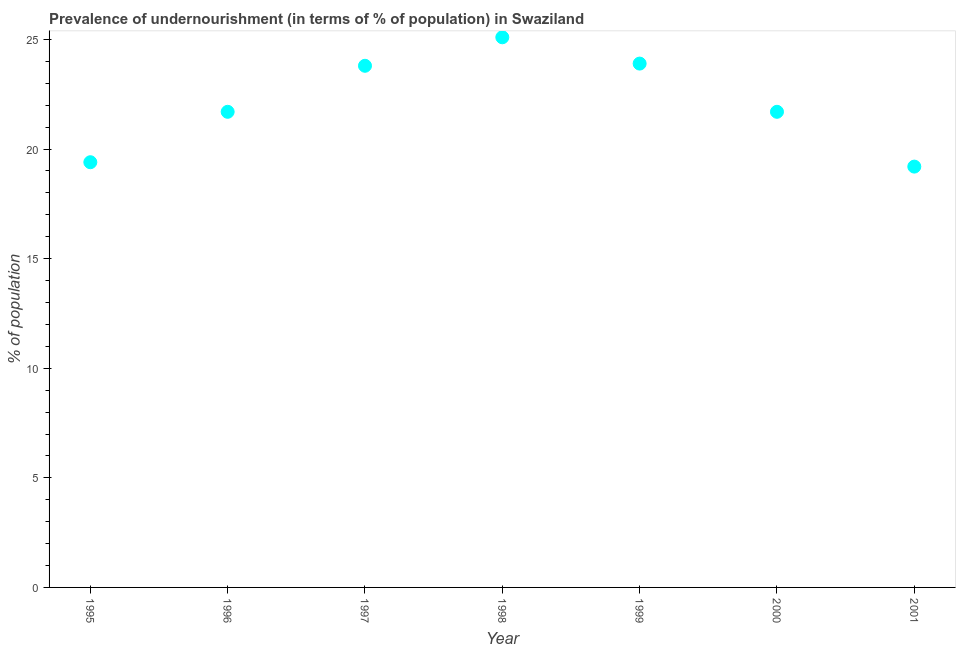What is the percentage of undernourished population in 1999?
Your answer should be compact. 23.9. Across all years, what is the maximum percentage of undernourished population?
Ensure brevity in your answer.  25.1. Across all years, what is the minimum percentage of undernourished population?
Your answer should be very brief. 19.2. In which year was the percentage of undernourished population maximum?
Give a very brief answer. 1998. What is the sum of the percentage of undernourished population?
Your response must be concise. 154.8. What is the difference between the percentage of undernourished population in 1996 and 1997?
Keep it short and to the point. -2.1. What is the average percentage of undernourished population per year?
Offer a terse response. 22.11. What is the median percentage of undernourished population?
Your response must be concise. 21.7. Do a majority of the years between 1997 and 1996 (inclusive) have percentage of undernourished population greater than 5 %?
Your answer should be very brief. No. What is the ratio of the percentage of undernourished population in 1998 to that in 2001?
Your response must be concise. 1.31. Is the difference between the percentage of undernourished population in 1998 and 2000 greater than the difference between any two years?
Provide a short and direct response. No. What is the difference between the highest and the second highest percentage of undernourished population?
Your answer should be very brief. 1.2. What is the difference between the highest and the lowest percentage of undernourished population?
Give a very brief answer. 5.9. Does the percentage of undernourished population monotonically increase over the years?
Offer a very short reply. No. What is the title of the graph?
Your answer should be very brief. Prevalence of undernourishment (in terms of % of population) in Swaziland. What is the label or title of the Y-axis?
Keep it short and to the point. % of population. What is the % of population in 1996?
Give a very brief answer. 21.7. What is the % of population in 1997?
Offer a very short reply. 23.8. What is the % of population in 1998?
Ensure brevity in your answer.  25.1. What is the % of population in 1999?
Provide a short and direct response. 23.9. What is the % of population in 2000?
Give a very brief answer. 21.7. What is the % of population in 2001?
Your answer should be very brief. 19.2. What is the difference between the % of population in 1995 and 1996?
Your answer should be compact. -2.3. What is the difference between the % of population in 1995 and 1997?
Keep it short and to the point. -4.4. What is the difference between the % of population in 1995 and 1999?
Offer a terse response. -4.5. What is the difference between the % of population in 1996 and 1998?
Provide a short and direct response. -3.4. What is the difference between the % of population in 1996 and 1999?
Provide a succinct answer. -2.2. What is the difference between the % of population in 1997 and 1998?
Offer a terse response. -1.3. What is the difference between the % of population in 1997 and 2000?
Provide a succinct answer. 2.1. What is the difference between the % of population in 1998 and 2000?
Your response must be concise. 3.4. What is the difference between the % of population in 1999 and 2001?
Keep it short and to the point. 4.7. What is the ratio of the % of population in 1995 to that in 1996?
Give a very brief answer. 0.89. What is the ratio of the % of population in 1995 to that in 1997?
Provide a succinct answer. 0.81. What is the ratio of the % of population in 1995 to that in 1998?
Your answer should be very brief. 0.77. What is the ratio of the % of population in 1995 to that in 1999?
Provide a succinct answer. 0.81. What is the ratio of the % of population in 1995 to that in 2000?
Your answer should be compact. 0.89. What is the ratio of the % of population in 1995 to that in 2001?
Your response must be concise. 1.01. What is the ratio of the % of population in 1996 to that in 1997?
Your answer should be very brief. 0.91. What is the ratio of the % of population in 1996 to that in 1998?
Ensure brevity in your answer.  0.86. What is the ratio of the % of population in 1996 to that in 1999?
Keep it short and to the point. 0.91. What is the ratio of the % of population in 1996 to that in 2000?
Your response must be concise. 1. What is the ratio of the % of population in 1996 to that in 2001?
Offer a terse response. 1.13. What is the ratio of the % of population in 1997 to that in 1998?
Provide a short and direct response. 0.95. What is the ratio of the % of population in 1997 to that in 2000?
Offer a very short reply. 1.1. What is the ratio of the % of population in 1997 to that in 2001?
Make the answer very short. 1.24. What is the ratio of the % of population in 1998 to that in 2000?
Your answer should be compact. 1.16. What is the ratio of the % of population in 1998 to that in 2001?
Keep it short and to the point. 1.31. What is the ratio of the % of population in 1999 to that in 2000?
Offer a very short reply. 1.1. What is the ratio of the % of population in 1999 to that in 2001?
Keep it short and to the point. 1.25. What is the ratio of the % of population in 2000 to that in 2001?
Your answer should be compact. 1.13. 